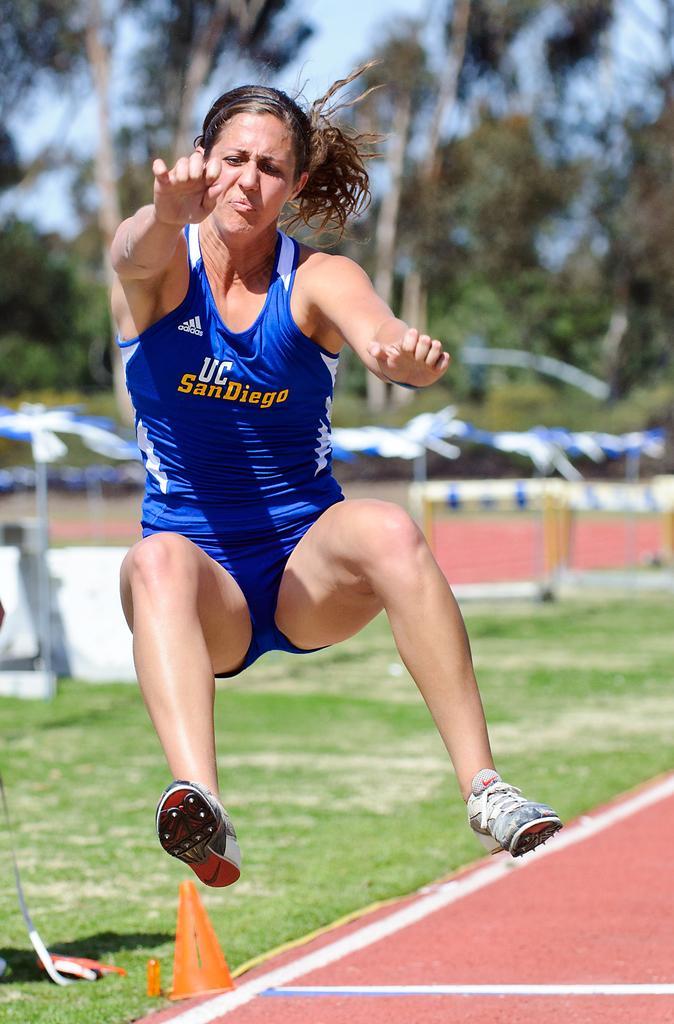In one or two sentences, can you explain what this image depicts? In the front of the image I can see a woman is in the air. In the background of the image it is blurry. There is a traffic cone, grass, trees, sky and objects. 